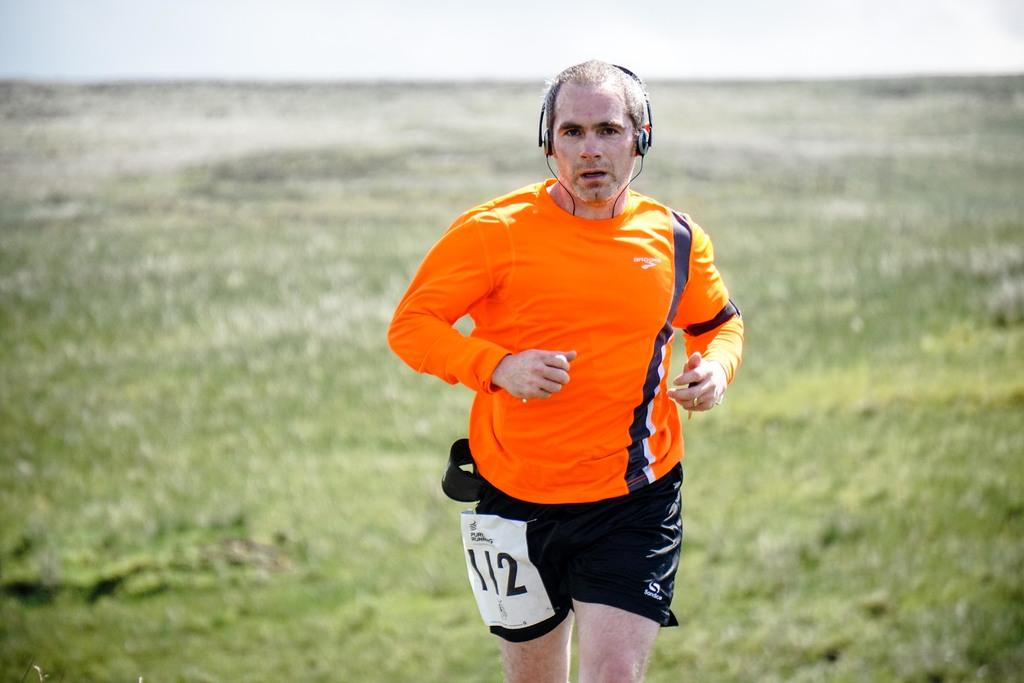What is the person in the image doing? The person is running in the image. What color combination is the person wearing? The person is wearing an orange and black color dress. What type of terrain is visible in the background of the image? There is grass visible in the background of the image. How is the background of the image depicted? The background is blurred. What day of the week is the person running on in the image? The day of the week is not mentioned or depicted in the image, so it cannot be determined. 